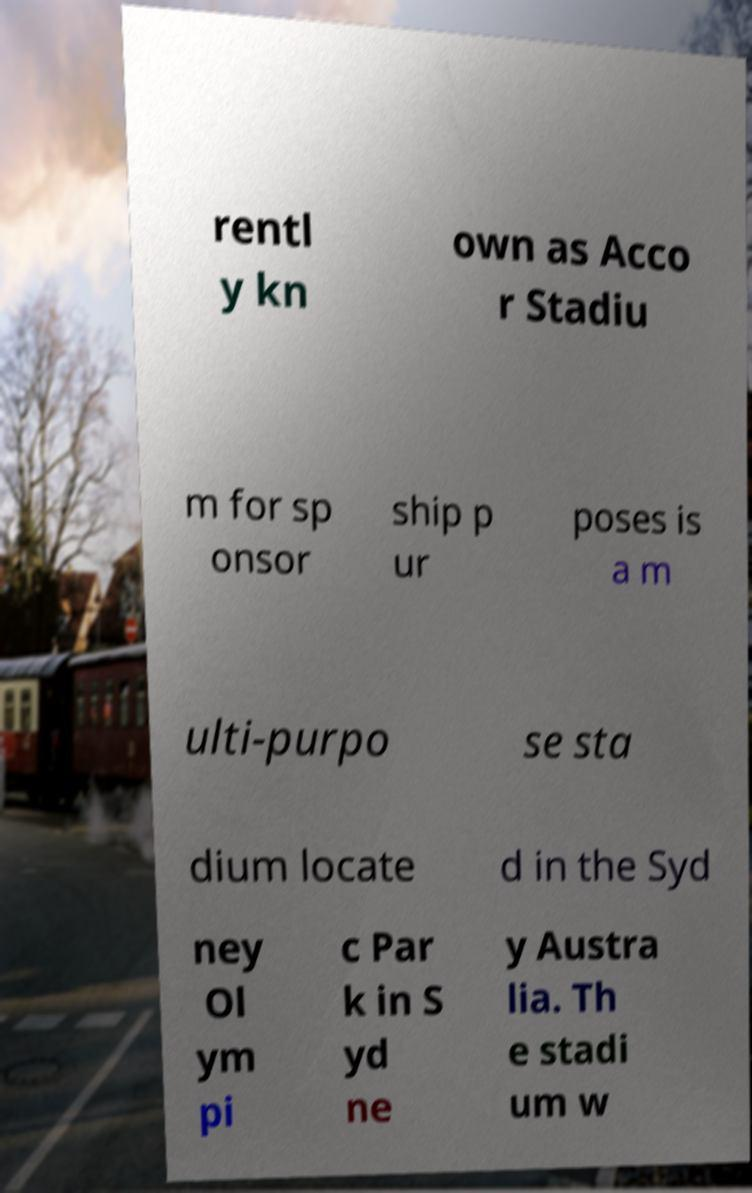Please identify and transcribe the text found in this image. rentl y kn own as Acco r Stadiu m for sp onsor ship p ur poses is a m ulti-purpo se sta dium locate d in the Syd ney Ol ym pi c Par k in S yd ne y Austra lia. Th e stadi um w 